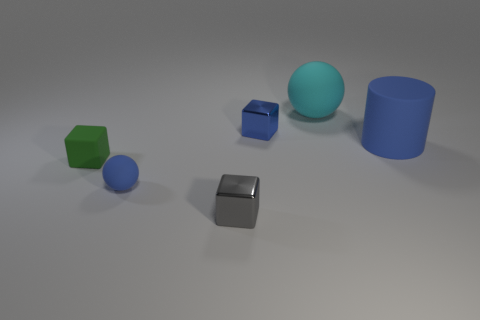Do the green block and the gray metal thing have the same size?
Provide a succinct answer. Yes. Are any blue metallic things visible?
Keep it short and to the point. Yes. Are there any big cyan things made of the same material as the tiny blue block?
Offer a terse response. No. What material is the other gray block that is the same size as the matte cube?
Give a very brief answer. Metal. How many other rubber objects are the same shape as the gray object?
Your response must be concise. 1. What is the size of the other blue object that is the same material as the big blue thing?
Give a very brief answer. Small. There is a small cube that is behind the tiny gray metallic block and in front of the large blue thing; what is its material?
Provide a succinct answer. Rubber. How many red matte things are the same size as the gray metallic block?
Your response must be concise. 0. There is a blue object that is the same shape as the small gray metal object; what is its material?
Your answer should be compact. Metal. What number of things are small metal things that are on the right side of the gray shiny block or matte objects that are to the right of the blue shiny thing?
Your answer should be very brief. 3. 